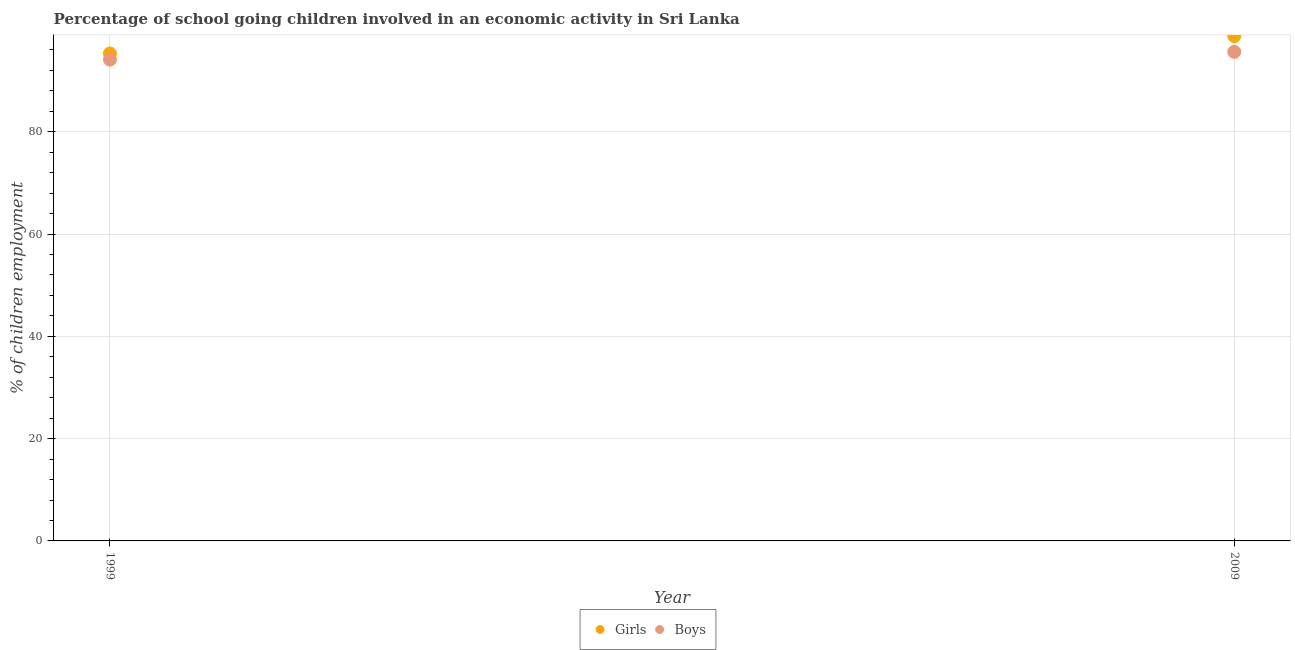Is the number of dotlines equal to the number of legend labels?
Offer a terse response. Yes. What is the percentage of school going girls in 2009?
Offer a very short reply. 98.71. Across all years, what is the maximum percentage of school going girls?
Your answer should be very brief. 98.71. Across all years, what is the minimum percentage of school going girls?
Keep it short and to the point. 95.3. In which year was the percentage of school going boys maximum?
Provide a short and direct response. 2009. In which year was the percentage of school going girls minimum?
Keep it short and to the point. 1999. What is the total percentage of school going girls in the graph?
Provide a succinct answer. 194.01. What is the difference between the percentage of school going boys in 1999 and that in 2009?
Keep it short and to the point. -1.52. What is the difference between the percentage of school going boys in 1999 and the percentage of school going girls in 2009?
Offer a very short reply. -4.61. What is the average percentage of school going boys per year?
Offer a very short reply. 94.86. In the year 2009, what is the difference between the percentage of school going girls and percentage of school going boys?
Keep it short and to the point. 3.08. What is the ratio of the percentage of school going boys in 1999 to that in 2009?
Your answer should be compact. 0.98. Is the percentage of school going boys in 1999 less than that in 2009?
Offer a terse response. Yes. Does the percentage of school going girls monotonically increase over the years?
Provide a succinct answer. Yes. How many dotlines are there?
Ensure brevity in your answer.  2. What is the difference between two consecutive major ticks on the Y-axis?
Provide a succinct answer. 20. Does the graph contain any zero values?
Your answer should be compact. No. How are the legend labels stacked?
Your answer should be compact. Horizontal. What is the title of the graph?
Ensure brevity in your answer.  Percentage of school going children involved in an economic activity in Sri Lanka. What is the label or title of the Y-axis?
Offer a terse response. % of children employment. What is the % of children employment of Girls in 1999?
Keep it short and to the point. 95.3. What is the % of children employment in Boys in 1999?
Offer a very short reply. 94.1. What is the % of children employment in Girls in 2009?
Provide a succinct answer. 98.71. What is the % of children employment of Boys in 2009?
Offer a terse response. 95.62. Across all years, what is the maximum % of children employment of Girls?
Offer a very short reply. 98.71. Across all years, what is the maximum % of children employment in Boys?
Provide a short and direct response. 95.62. Across all years, what is the minimum % of children employment in Girls?
Provide a short and direct response. 95.3. Across all years, what is the minimum % of children employment in Boys?
Ensure brevity in your answer.  94.1. What is the total % of children employment of Girls in the graph?
Offer a very short reply. 194. What is the total % of children employment in Boys in the graph?
Offer a terse response. 189.72. What is the difference between the % of children employment of Girls in 1999 and that in 2009?
Give a very brief answer. -3.4. What is the difference between the % of children employment in Boys in 1999 and that in 2009?
Offer a terse response. -1.52. What is the difference between the % of children employment of Girls in 1999 and the % of children employment of Boys in 2009?
Your answer should be very brief. -0.32. What is the average % of children employment of Girls per year?
Provide a succinct answer. 97. What is the average % of children employment in Boys per year?
Your answer should be compact. 94.86. In the year 2009, what is the difference between the % of children employment of Girls and % of children employment of Boys?
Ensure brevity in your answer.  3.08. What is the ratio of the % of children employment in Girls in 1999 to that in 2009?
Make the answer very short. 0.97. What is the ratio of the % of children employment in Boys in 1999 to that in 2009?
Offer a terse response. 0.98. What is the difference between the highest and the second highest % of children employment of Girls?
Ensure brevity in your answer.  3.4. What is the difference between the highest and the second highest % of children employment of Boys?
Offer a terse response. 1.52. What is the difference between the highest and the lowest % of children employment of Girls?
Your answer should be compact. 3.4. What is the difference between the highest and the lowest % of children employment in Boys?
Provide a short and direct response. 1.52. 